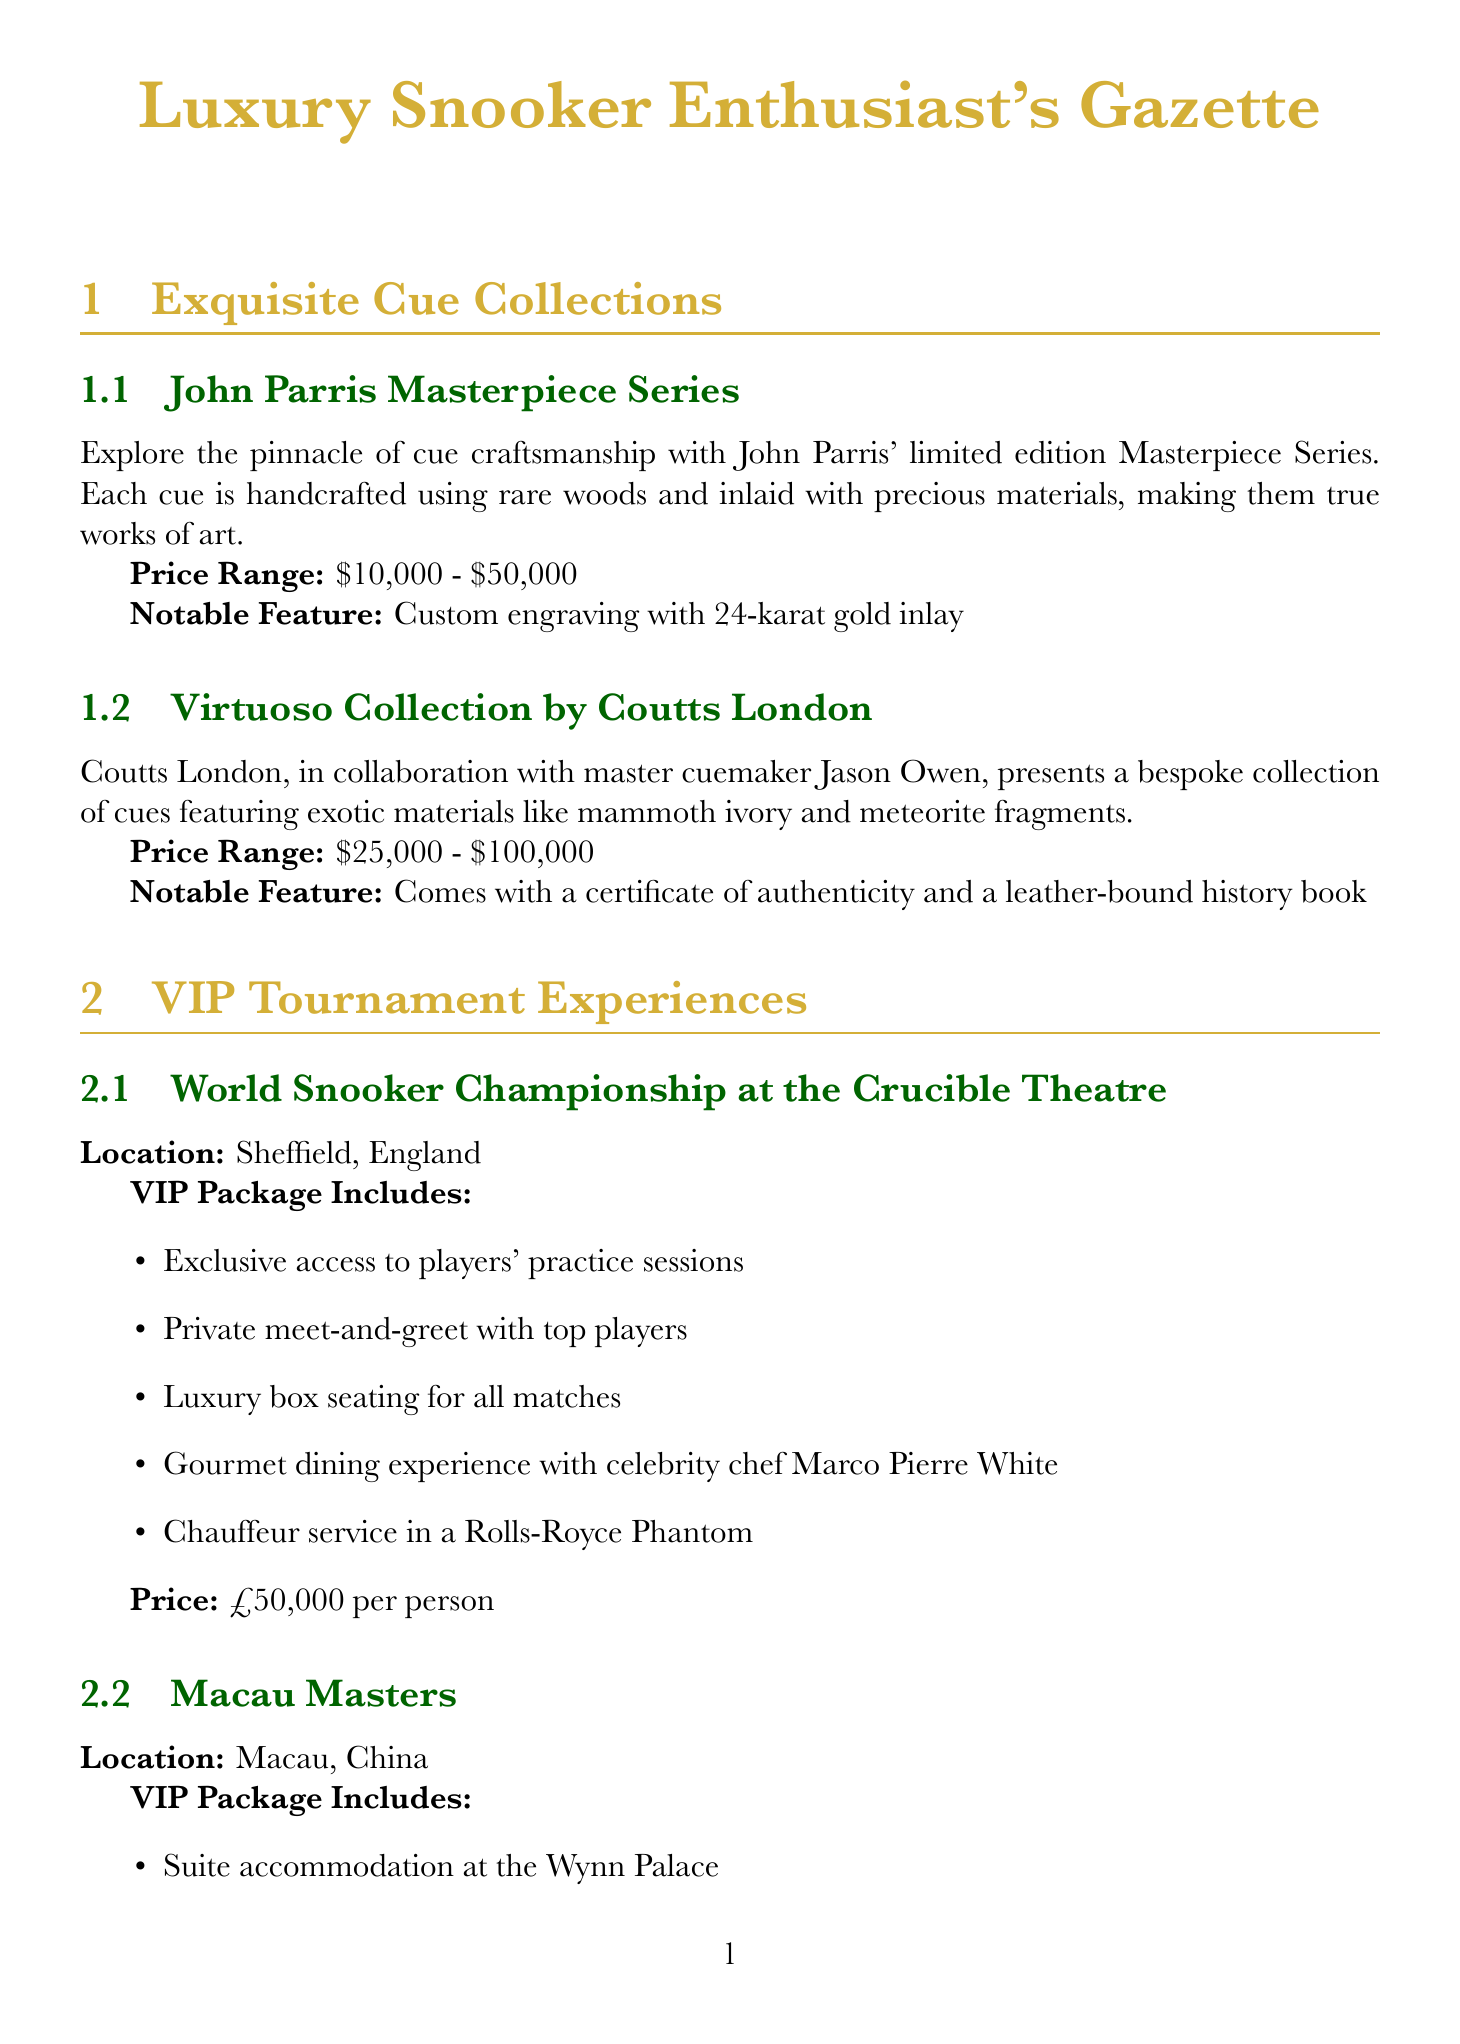What is the price range of the John Parris Masterpiece Series? The price range is listed in the document as $10,000 - $50,000.
Answer: $10,000 - $50,000 What notable feature does the Virtuoso Collection include? The document states that this collection comes with a certificate of authenticity and a leather-bound history book.
Answer: Certificate of authenticity and leather-bound history book What event is hosted at the Crucible Theatre? The event mentioned in the document for this location is the World Snooker Championship.
Answer: World Snooker Championship What is included in the VIP package for the Macau Masters? The VIP package includes a suite accommodation at the Wynn Palace and a private snooker lesson among other benefits.
Answer: Suite accommodation at the Wynn Palace How much does a 5-night stay at The Balmoral cost? The document specifies that the package price for a 5-night stay at The Balmoral is £15,000.
Answer: £15,000 What unique experience is offered at Aman Tokyo? The document describes offering a private lesson with Japanese snooker pro Michie Sato.
Answer: Private lesson with Michie Sato How much can a donor contribute to be a Global Ambassador in the 'Cues for Change' Program? The donation tier for a Global Ambassador starts from £250,000 according to the document.
Answer: £250,000 What philanthropic initiative involves Ronnie O'Sullivan? The document mentions the Ronnie O'Sullivan Academy for Underprivileged Youth as the initiative.
Answer: Ronnie O'Sullivan Academy for Underprivileged Youth 